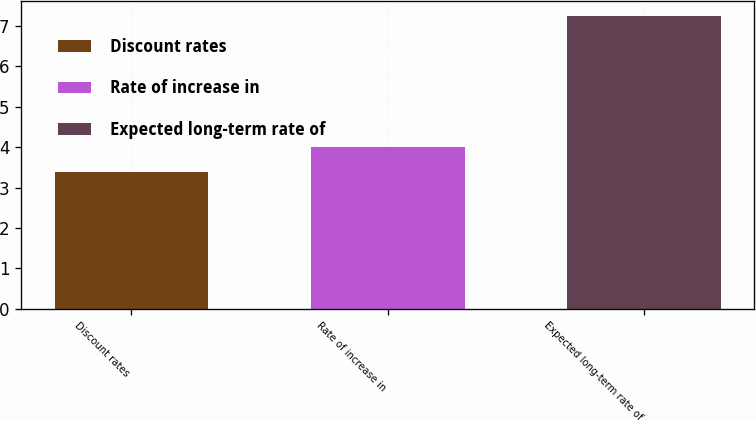Convert chart. <chart><loc_0><loc_0><loc_500><loc_500><bar_chart><fcel>Discount rates<fcel>Rate of increase in<fcel>Expected long-term rate of<nl><fcel>3.39<fcel>4<fcel>7.25<nl></chart> 